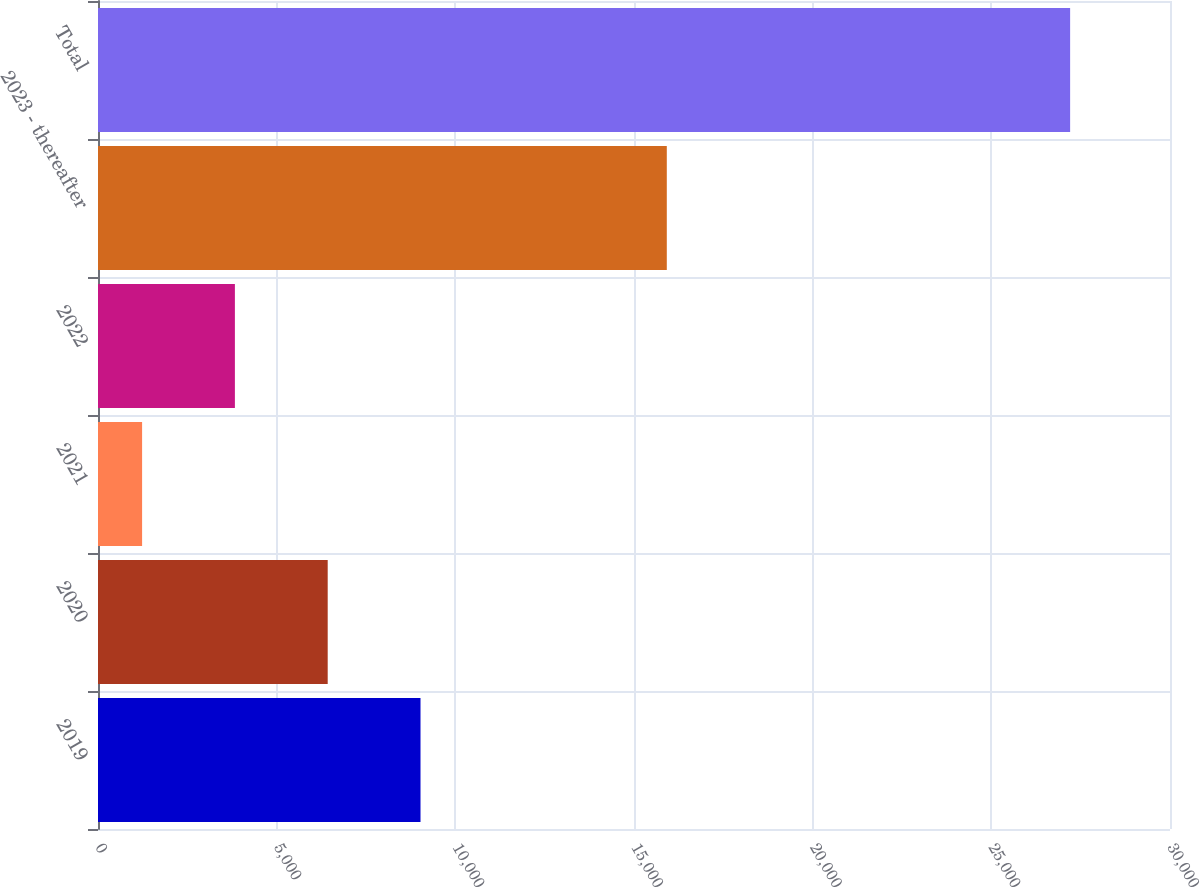<chart> <loc_0><loc_0><loc_500><loc_500><bar_chart><fcel>2019<fcel>2020<fcel>2021<fcel>2022<fcel>2023 - thereafter<fcel>Total<nl><fcel>9025.3<fcel>6428.2<fcel>1234<fcel>3831.1<fcel>15918<fcel>27205<nl></chart> 